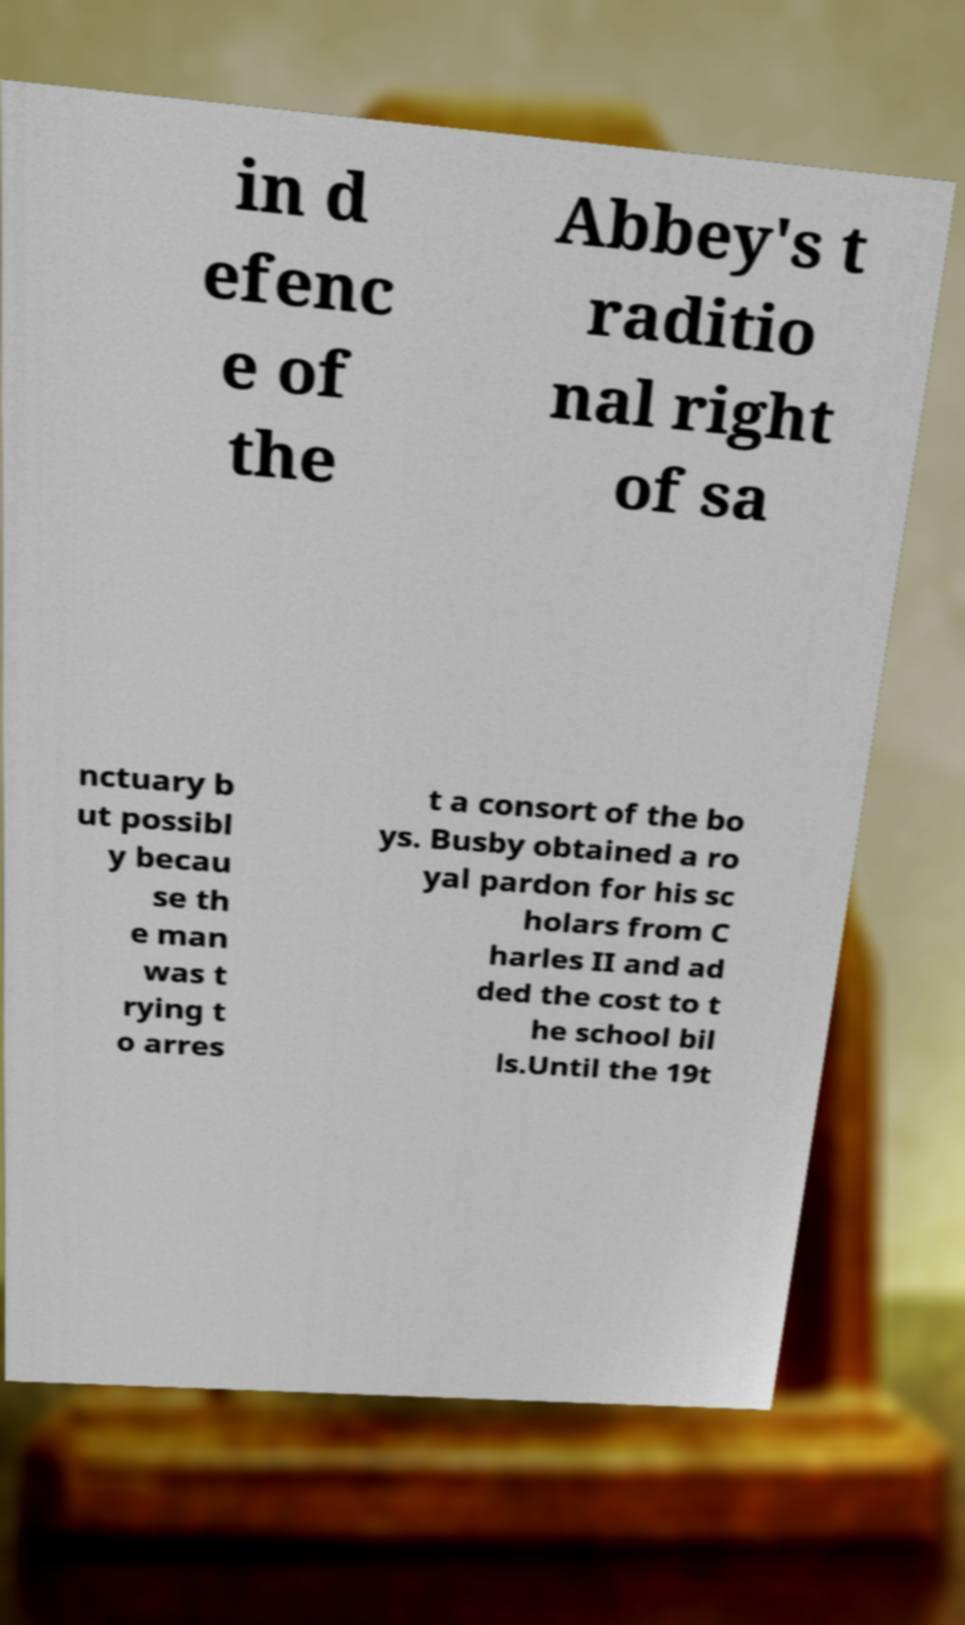Could you extract and type out the text from this image? in d efenc e of the Abbey's t raditio nal right of sa nctuary b ut possibl y becau se th e man was t rying t o arres t a consort of the bo ys. Busby obtained a ro yal pardon for his sc holars from C harles II and ad ded the cost to t he school bil ls.Until the 19t 